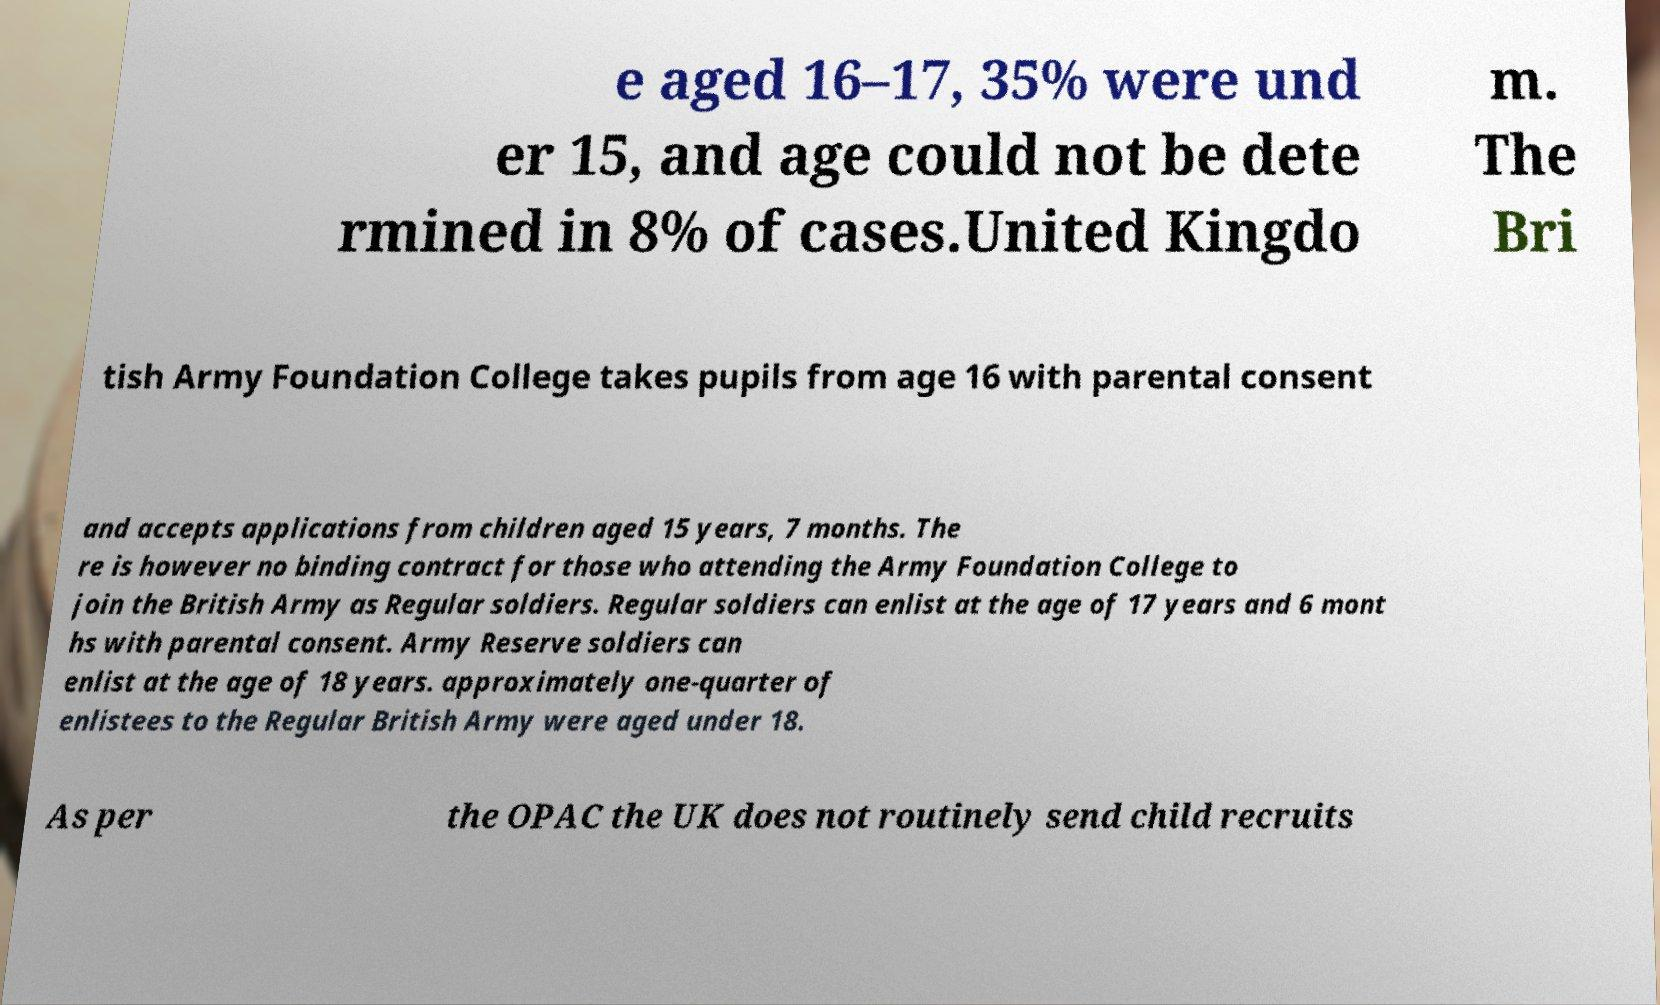For documentation purposes, I need the text within this image transcribed. Could you provide that? e aged 16–17, 35% were und er 15, and age could not be dete rmined in 8% of cases.United Kingdo m. The Bri tish Army Foundation College takes pupils from age 16 with parental consent and accepts applications from children aged 15 years, 7 months. The re is however no binding contract for those who attending the Army Foundation College to join the British Army as Regular soldiers. Regular soldiers can enlist at the age of 17 years and 6 mont hs with parental consent. Army Reserve soldiers can enlist at the age of 18 years. approximately one-quarter of enlistees to the Regular British Army were aged under 18. As per the OPAC the UK does not routinely send child recruits 